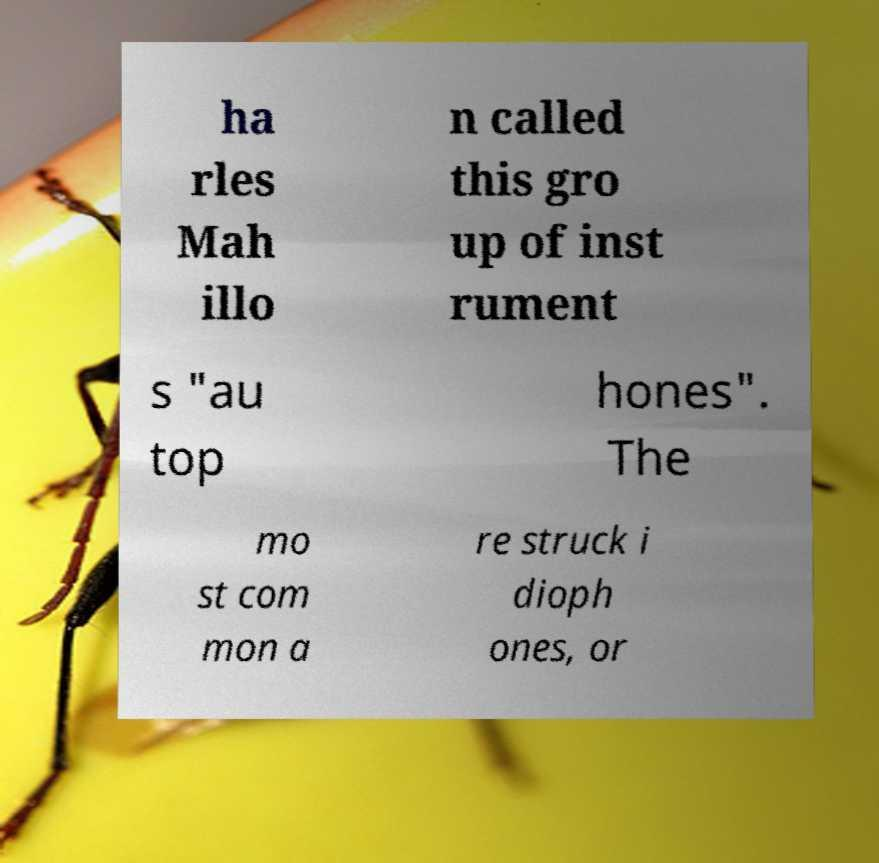There's text embedded in this image that I need extracted. Can you transcribe it verbatim? ha rles Mah illo n called this gro up of inst rument s "au top hones". The mo st com mon a re struck i dioph ones, or 